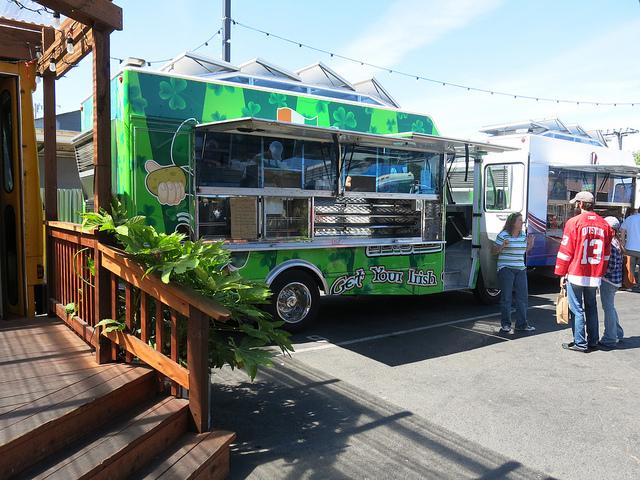Is this in a foreign country?
Concise answer only. No. Are the people inside using computers?
Concise answer only. No. What number is on the man's shirt?
Be succinct. 13. Is this a food truck?
Answer briefly. Yes. What color is the truck?
Give a very brief answer. Green. 